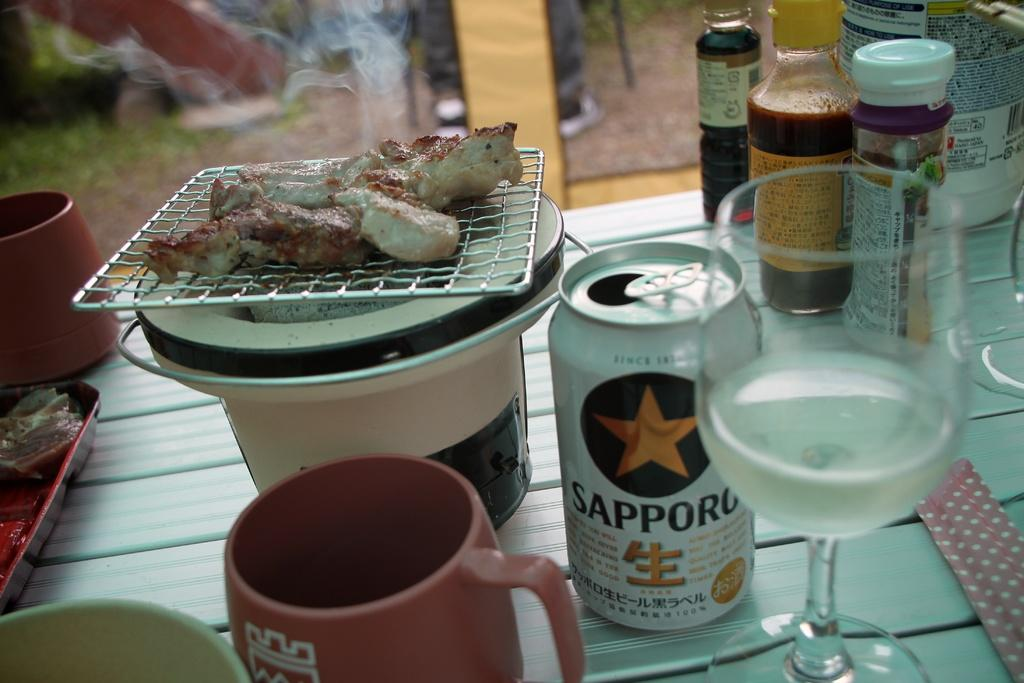<image>
Relay a brief, clear account of the picture shown. A can of Sapporo beer and a glass are next to a japanese grill with meat. 